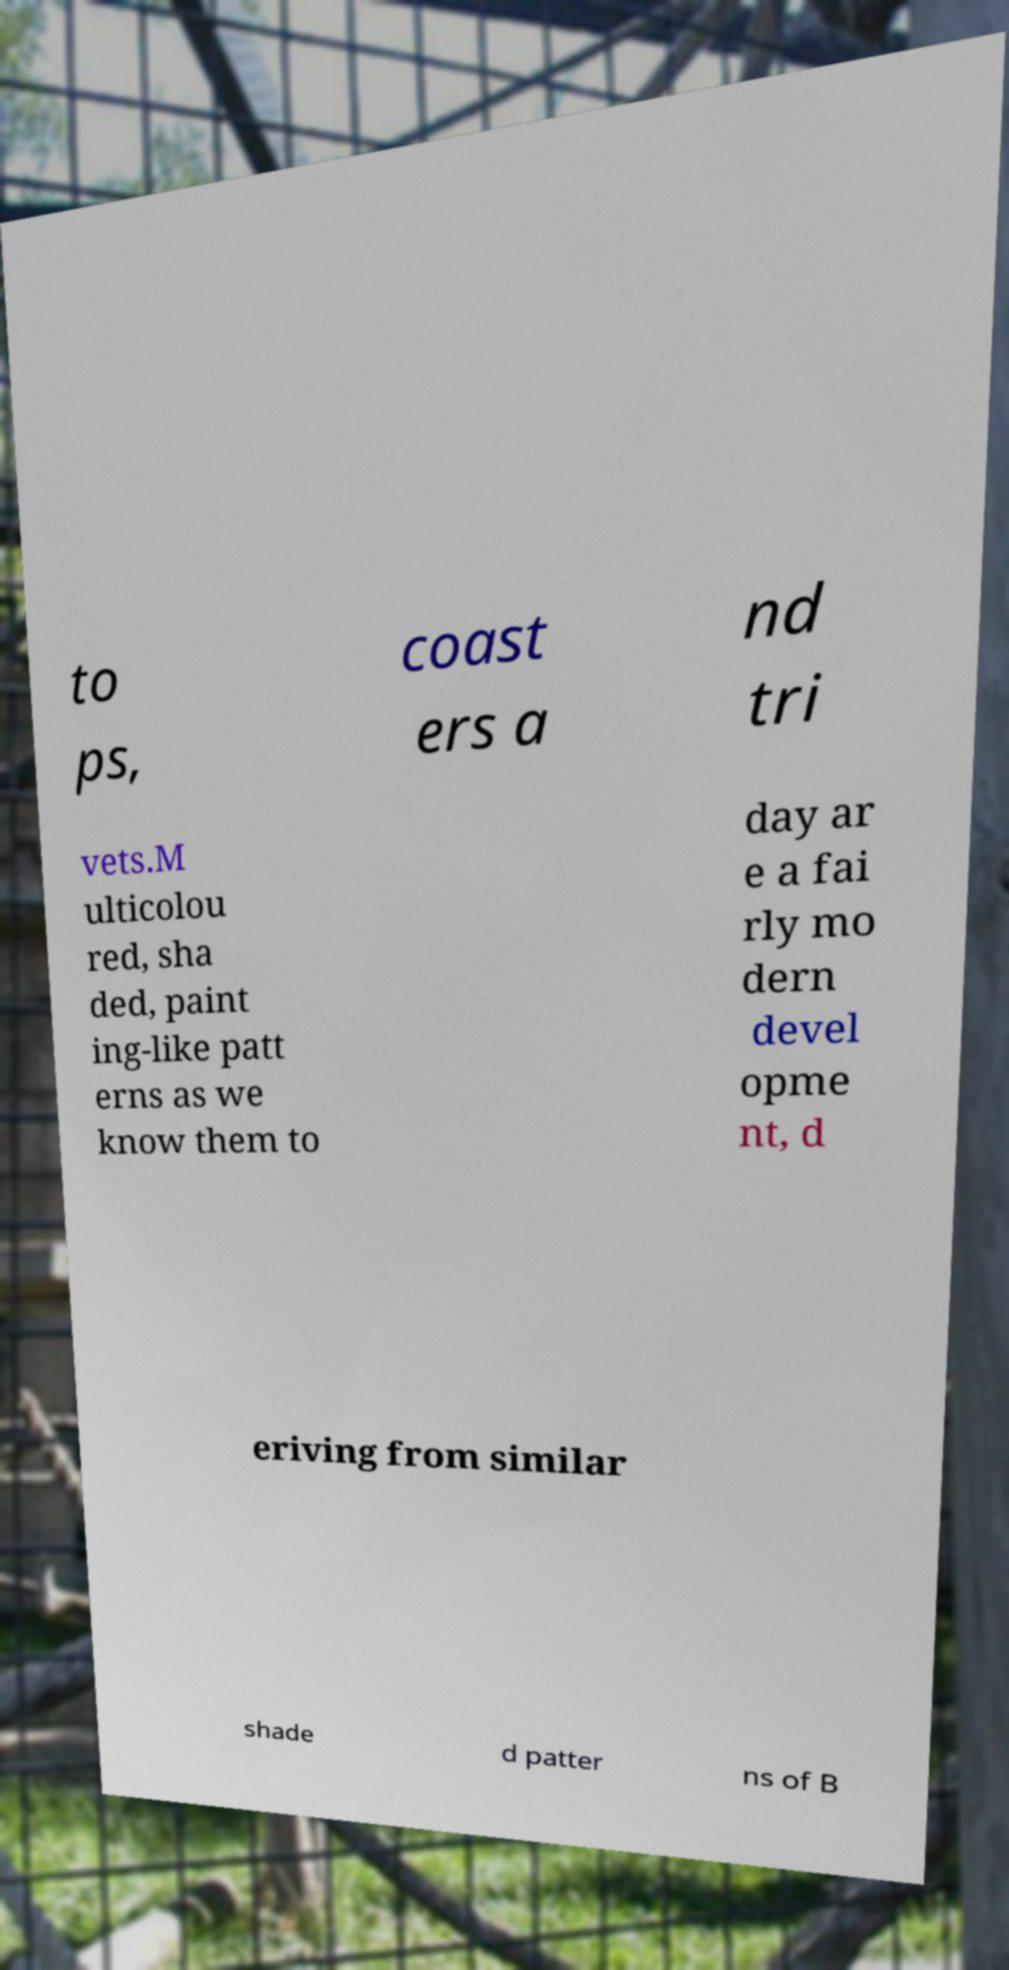Could you extract and type out the text from this image? to ps, coast ers a nd tri vets.M ulticolou red, sha ded, paint ing-like patt erns as we know them to day ar e a fai rly mo dern devel opme nt, d eriving from similar shade d patter ns of B 